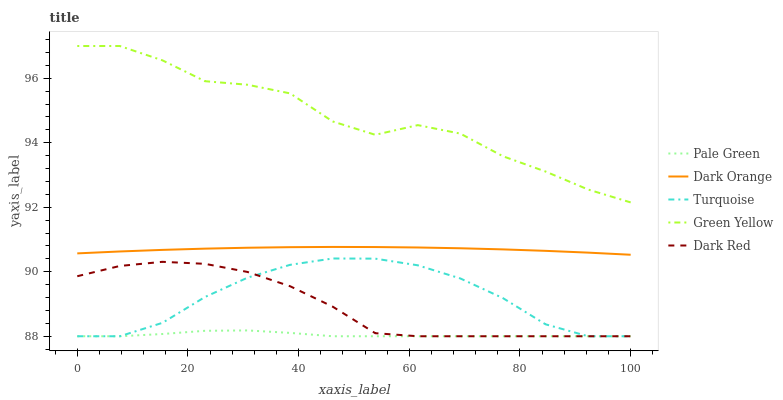Does Pale Green have the minimum area under the curve?
Answer yes or no. Yes. Does Green Yellow have the maximum area under the curve?
Answer yes or no. Yes. Does Turquoise have the minimum area under the curve?
Answer yes or no. No. Does Turquoise have the maximum area under the curve?
Answer yes or no. No. Is Dark Orange the smoothest?
Answer yes or no. Yes. Is Green Yellow the roughest?
Answer yes or no. Yes. Is Turquoise the smoothest?
Answer yes or no. No. Is Turquoise the roughest?
Answer yes or no. No. Does Turquoise have the lowest value?
Answer yes or no. Yes. Does Green Yellow have the lowest value?
Answer yes or no. No. Does Green Yellow have the highest value?
Answer yes or no. Yes. Does Turquoise have the highest value?
Answer yes or no. No. Is Dark Red less than Dark Orange?
Answer yes or no. Yes. Is Green Yellow greater than Dark Red?
Answer yes or no. Yes. Does Dark Red intersect Turquoise?
Answer yes or no. Yes. Is Dark Red less than Turquoise?
Answer yes or no. No. Is Dark Red greater than Turquoise?
Answer yes or no. No. Does Dark Red intersect Dark Orange?
Answer yes or no. No. 